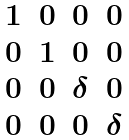Convert formula to latex. <formula><loc_0><loc_0><loc_500><loc_500>\begin{matrix} 1 & 0 & 0 & 0 \\ 0 & 1 & 0 & 0 \\ 0 & 0 & \delta & 0 \\ 0 & 0 & 0 & \delta \end{matrix}</formula> 